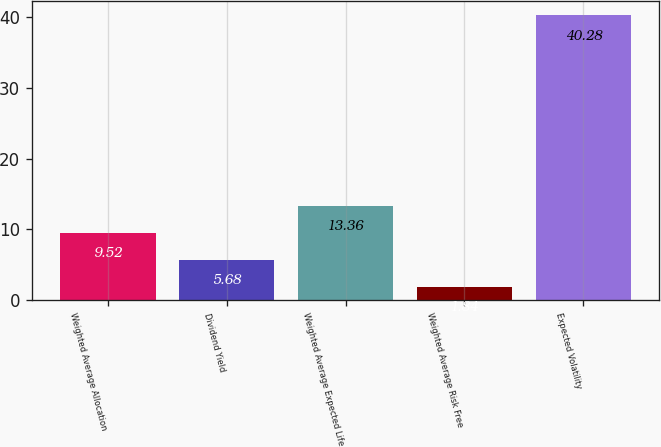<chart> <loc_0><loc_0><loc_500><loc_500><bar_chart><fcel>Weighted Average Allocation<fcel>Dividend Yield<fcel>Weighted Average Expected Life<fcel>Weighted Average Risk Free<fcel>Expected Volatility<nl><fcel>9.52<fcel>5.68<fcel>13.36<fcel>1.84<fcel>40.28<nl></chart> 